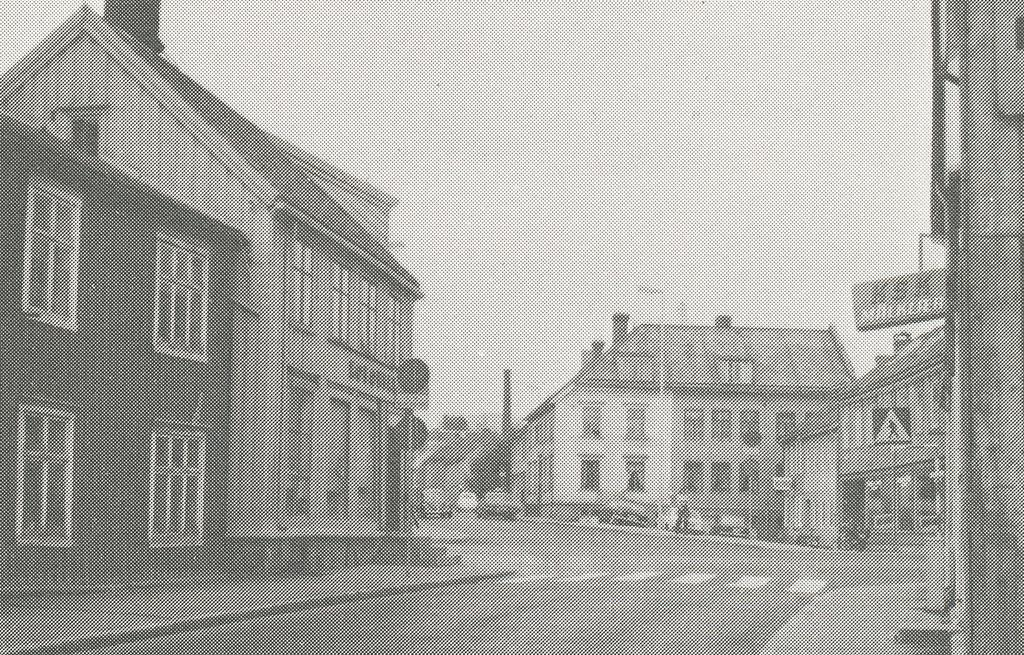Provide a one-sentence caption for the provided image. An old road with a sign that reads KSK on one of the buildings on the right. 